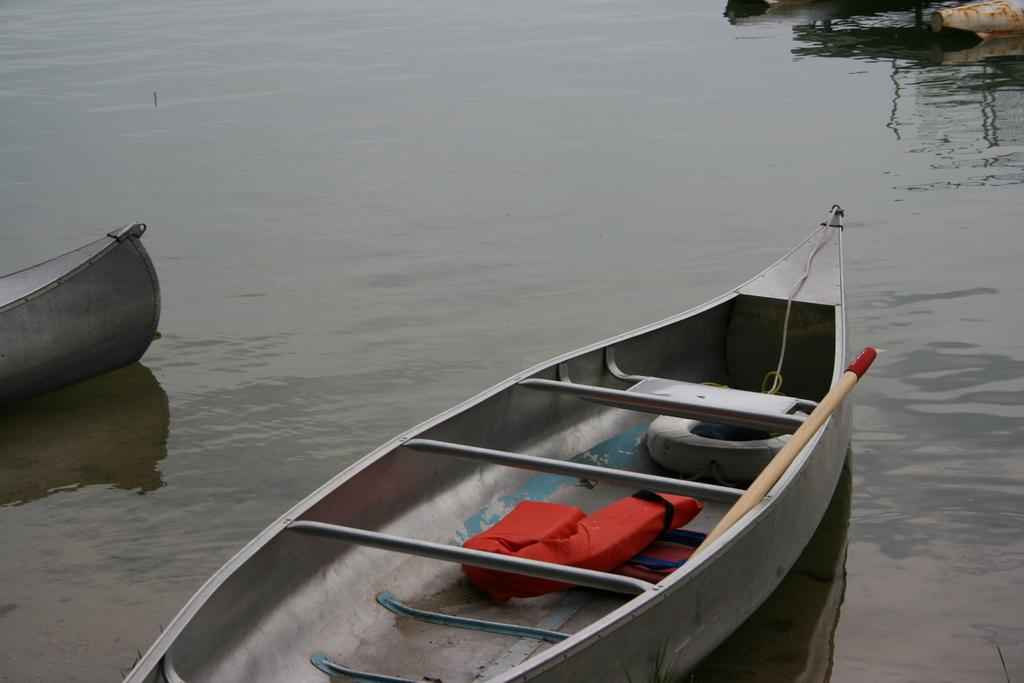What type of vehicles are in the water in the image? There are boats in the water in the image. What is attached to the front of the boat? A paddle and a Tyre are present on the front boat. Can you describe the paddle on the front boat? The paddle is an oar-like tool used for propelling the boat through the water. Where is the store located in the image? There is no store present in the image; it features boats in the water. What type of sound can be heard from the geese in the image? There are no geese present in the image, so no such sound can be heard. 